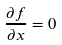Convert formula to latex. <formula><loc_0><loc_0><loc_500><loc_500>\frac { \partial f } { \partial x } = 0</formula> 